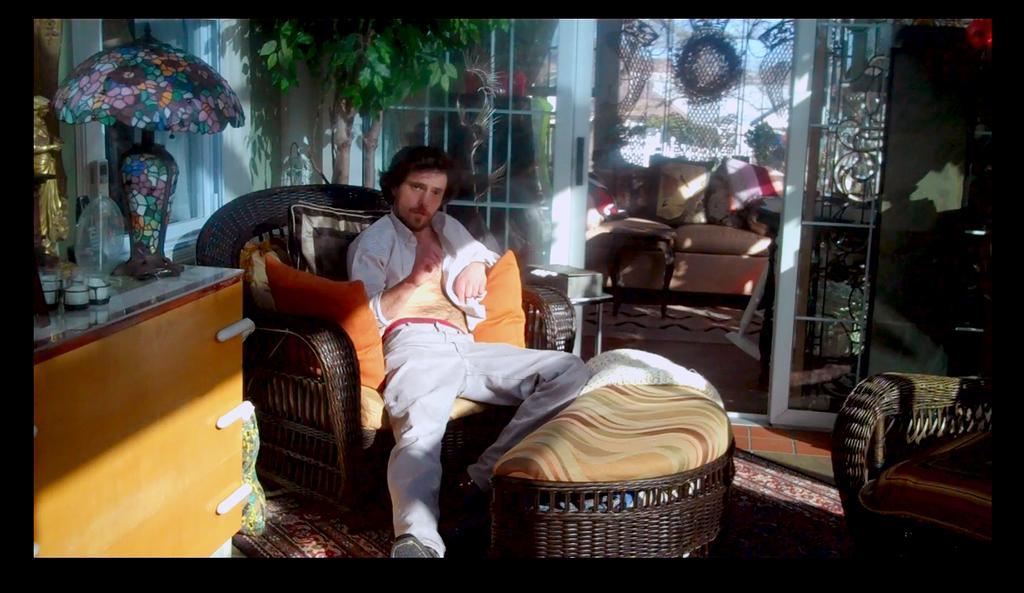Please provide a concise description of this image. In this image, we can see cushions on the sofas and there is a person sitting on one of the sofa. In the background, there is a plant and we can see some stands and there are decor items. At the bottom, there is a carpet on the floor. 